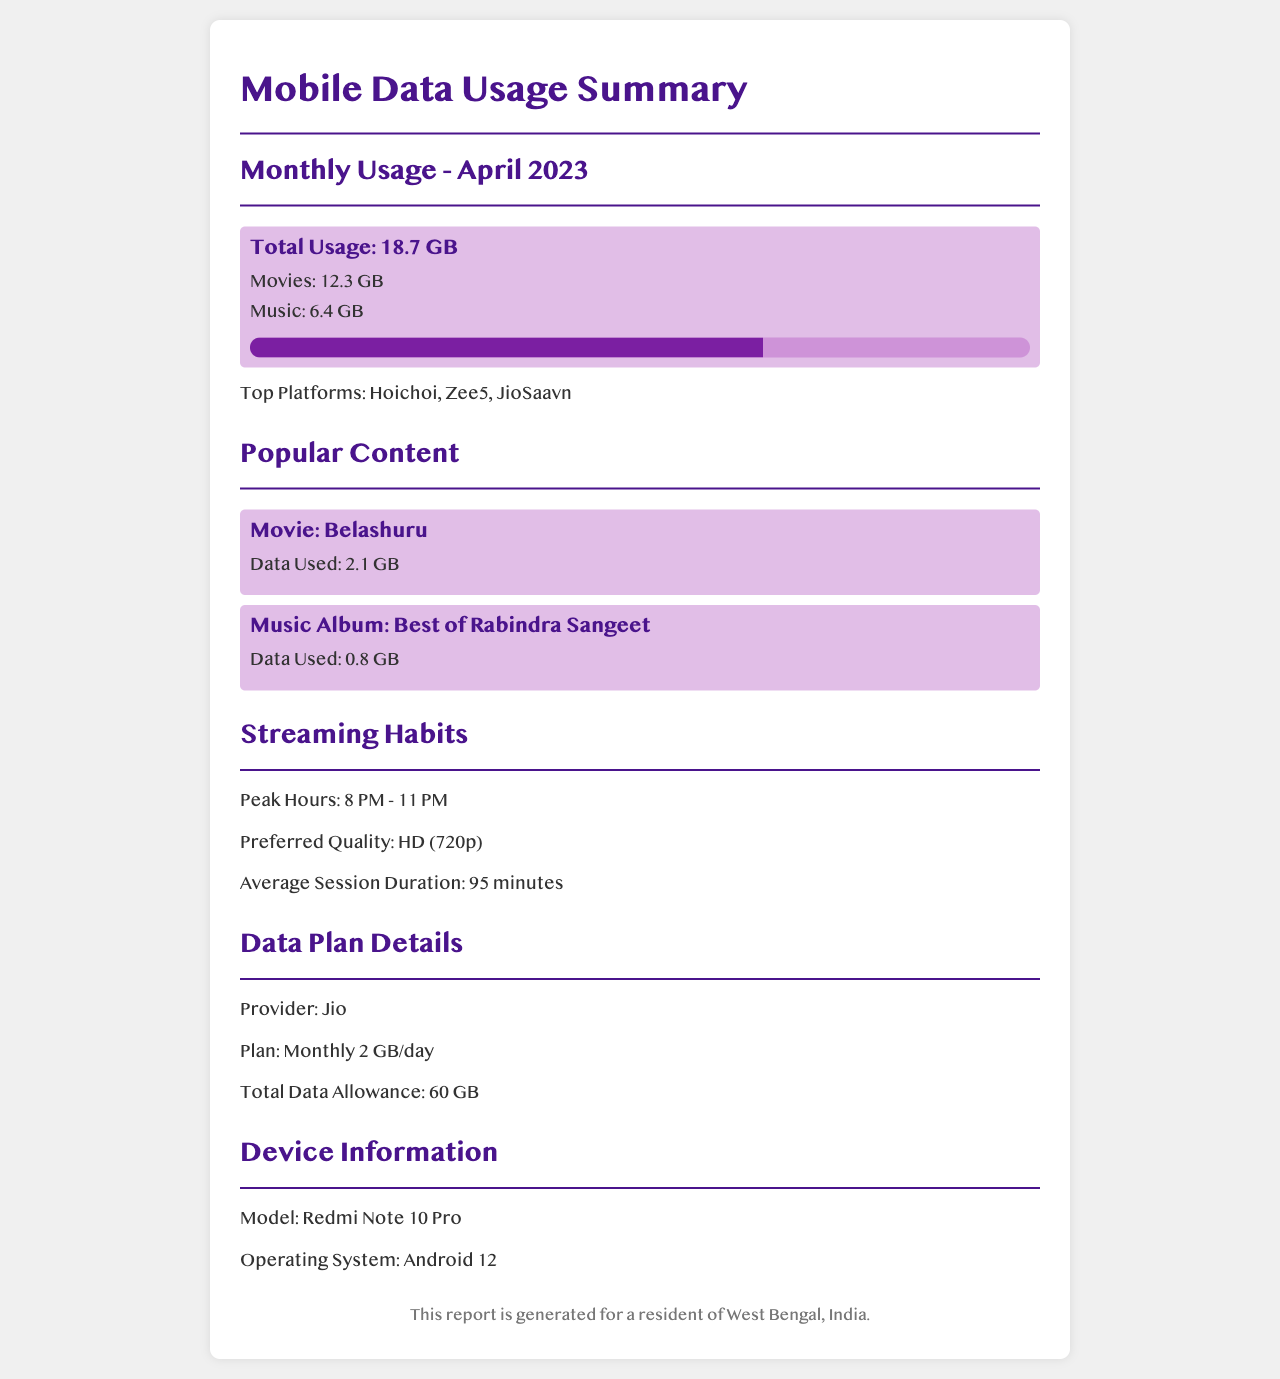what was the total data usage for April 2023? The total usage mentioned in the document for April 2023 is 18.7 GB.
Answer: 18.7 GB how much data was used for movies? The document states that 12.3 GB was used for movies in April 2023.
Answer: 12.3 GB who are the top platforms mentioned? The document lists Hoichoi, Zee5, and JioSaavn as the top platforms.
Answer: Hoichoi, Zee5, JioSaavn what is the average session duration for streaming? The average session duration provided in the document is 95 minutes.
Answer: 95 minutes what is the streaming peak hour range? The peak hours for streaming according to the document are from 8 PM to 11 PM.
Answer: 8 PM - 11 PM which movie consumed the most data? The document mentions the movie "Belashuru" as using 2.1 GB of data.
Answer: Belashuru what is the data plan specified in the document? The document specifies a monthly plan of 2 GB per day, which equates to 60 GB total.
Answer: Monthly 2 GB/day which device model is mentioned? The document states that the device used is a Redmi Note 10 Pro.
Answer: Redmi Note 10 Pro 